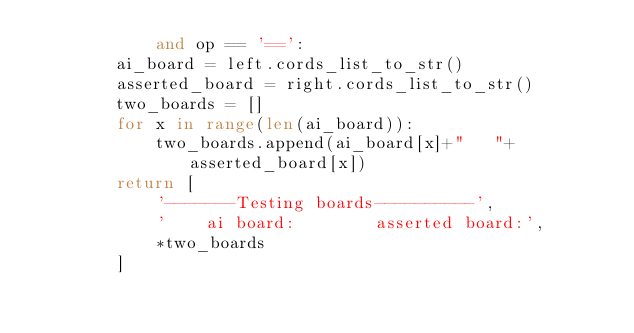<code> <loc_0><loc_0><loc_500><loc_500><_Python_>            and op == '==':
        ai_board = left.cords_list_to_str()
        asserted_board = right.cords_list_to_str()
        two_boards = []
        for x in range(len(ai_board)):
            two_boards.append(ai_board[x]+"   "+asserted_board[x])
        return [
            '-------Testing boards----------',
            '    ai board:        asserted board:',
            *two_boards
        ]
</code> 